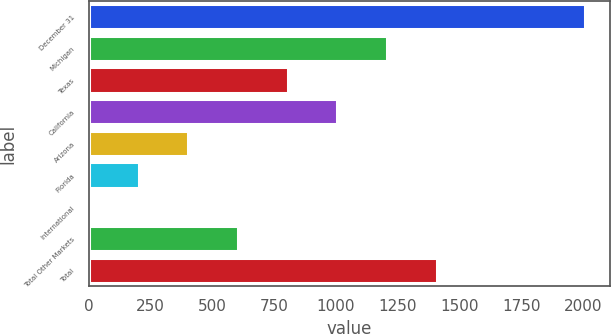<chart> <loc_0><loc_0><loc_500><loc_500><bar_chart><fcel>December 31<fcel>Michigan<fcel>Texas<fcel>California<fcel>Arizona<fcel>Florida<fcel>International<fcel>Total Other Markets<fcel>Total<nl><fcel>2010<fcel>1206.4<fcel>804.6<fcel>1005.5<fcel>402.8<fcel>201.9<fcel>1<fcel>603.7<fcel>1407.3<nl></chart> 